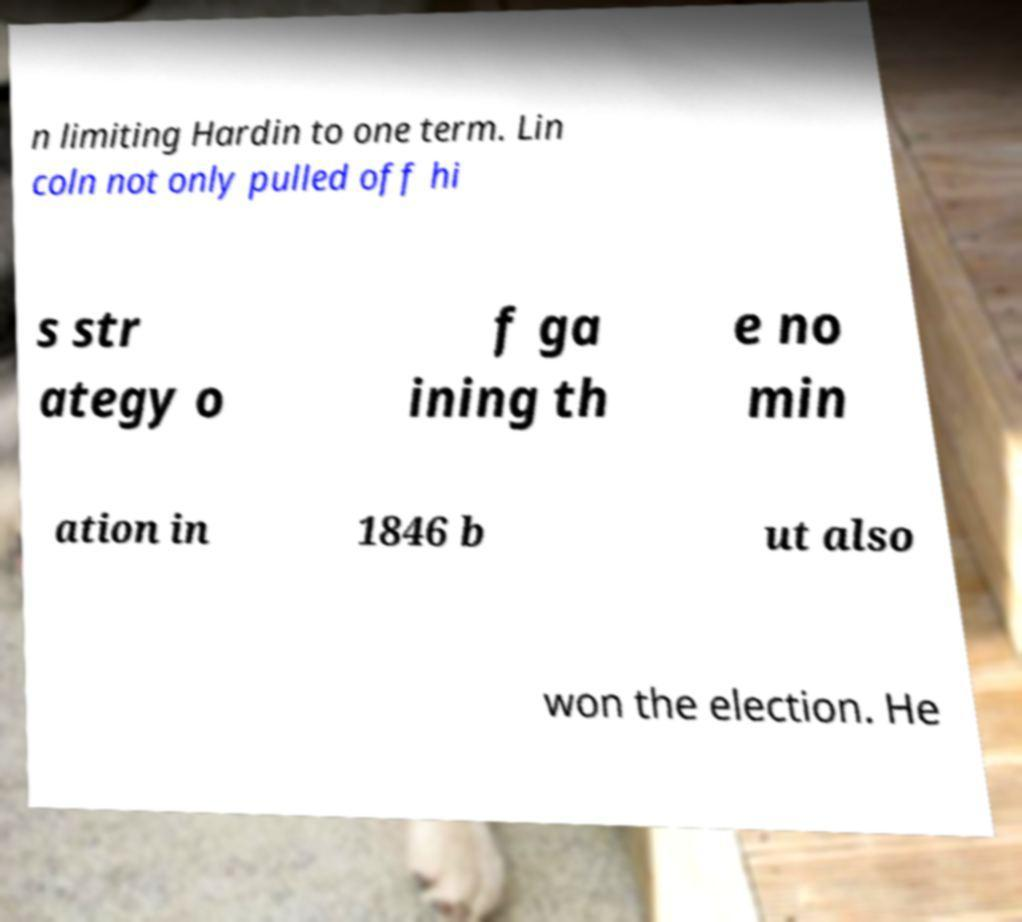There's text embedded in this image that I need extracted. Can you transcribe it verbatim? n limiting Hardin to one term. Lin coln not only pulled off hi s str ategy o f ga ining th e no min ation in 1846 b ut also won the election. He 